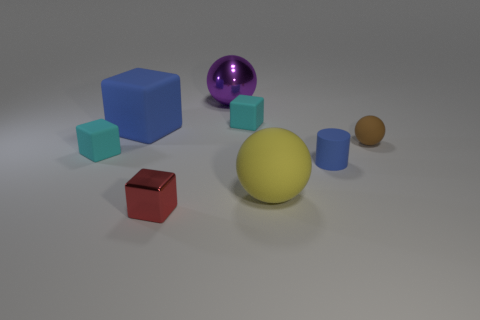Subtract all red cubes. How many cubes are left? 3 Add 1 gray metal objects. How many objects exist? 9 Subtract all large blocks. How many blocks are left? 3 Subtract 1 balls. How many balls are left? 2 Subtract all small matte spheres. Subtract all small red metallic objects. How many objects are left? 6 Add 1 brown balls. How many brown balls are left? 2 Add 6 tiny rubber spheres. How many tiny rubber spheres exist? 7 Subtract 0 gray cylinders. How many objects are left? 8 Subtract all balls. How many objects are left? 5 Subtract all purple spheres. Subtract all gray cubes. How many spheres are left? 2 